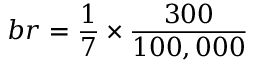Convert formula to latex. <formula><loc_0><loc_0><loc_500><loc_500>b r = \frac { 1 } { 7 } \times \frac { 3 0 0 } { 1 0 0 , 0 0 0 }</formula> 